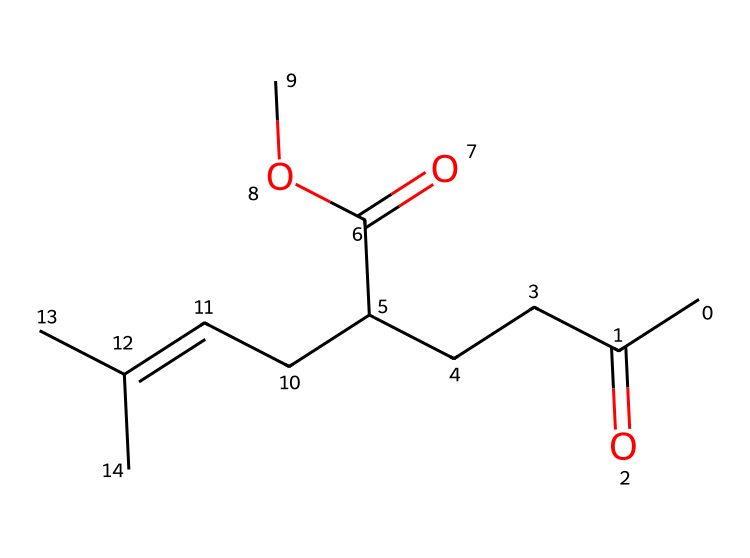how many carbon atoms are in this molecule? Count the number of carbon (C) symbols in the SMILES representation. The representation has a total of 9 carbon atoms in its structure.
Answer: 9 how many double bonds are present in this compound? Look for instances of '=' which indicate double bonds in the SMILES. There are 2 double bonds present in the structure.
Answer: 2 what functional groups are present in this molecule? Identify the functional groups based on common characteristics in the SMILES. The molecule contains an ester (indicated by 'OC') and ketones (indicated by 'C(=O)').
Answer: ester, ketone what is the molecular formula of this chemical? Count the individual atoms based on the SMILES. This results in the formula C12H22O3 when considering the number of each type of atom.
Answer: C12H22O3 how does the molecular structure of hedione influence its aroma profile? Analyze the entire structure: Hedione has aromatic features from the presence of the alkene (C=C) and the floral influence from the carbon chain. This combination gives it a jasmine-like, fresh floral scent.
Answer: floral is this compound a cage compound? Cage compounds typically feature a complex, closed, three-dimensional structure which is absent here; instead, this one has an open-chain structure typical of esters. Hence, hedione does not classify as a cage compound.
Answer: no 